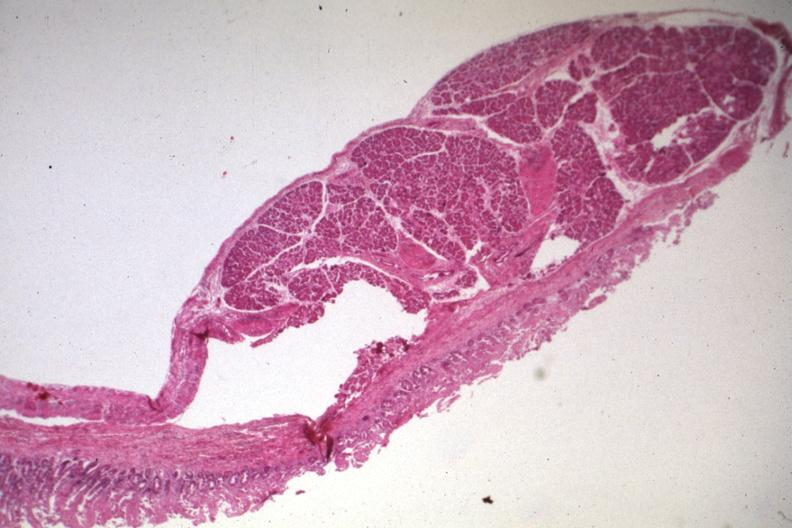s gastrointestinal present?
Answer the question using a single word or phrase. Yes 